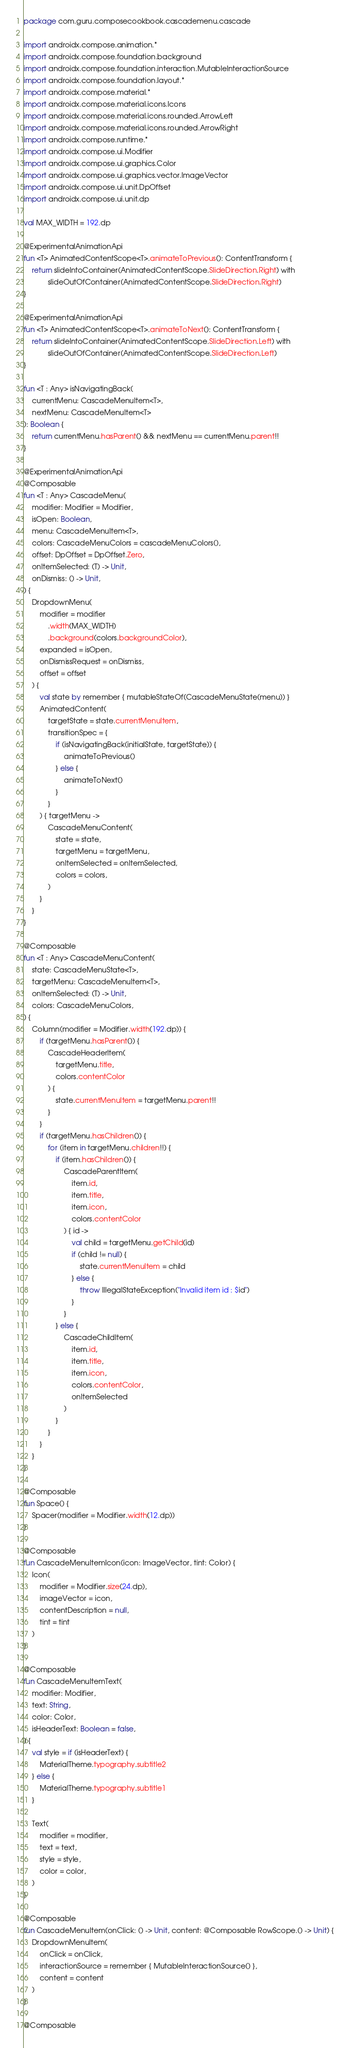<code> <loc_0><loc_0><loc_500><loc_500><_Kotlin_>package com.guru.composecookbook.cascademenu.cascade

import androidx.compose.animation.*
import androidx.compose.foundation.background
import androidx.compose.foundation.interaction.MutableInteractionSource
import androidx.compose.foundation.layout.*
import androidx.compose.material.*
import androidx.compose.material.icons.Icons
import androidx.compose.material.icons.rounded.ArrowLeft
import androidx.compose.material.icons.rounded.ArrowRight
import androidx.compose.runtime.*
import androidx.compose.ui.Modifier
import androidx.compose.ui.graphics.Color
import androidx.compose.ui.graphics.vector.ImageVector
import androidx.compose.ui.unit.DpOffset
import androidx.compose.ui.unit.dp

val MAX_WIDTH = 192.dp

@ExperimentalAnimationApi
fun <T> AnimatedContentScope<T>.animateToPrevious(): ContentTransform {
    return slideIntoContainer(AnimatedContentScope.SlideDirection.Right) with
            slideOutOfContainer(AnimatedContentScope.SlideDirection.Right)
}

@ExperimentalAnimationApi
fun <T> AnimatedContentScope<T>.animateToNext(): ContentTransform {
    return slideIntoContainer(AnimatedContentScope.SlideDirection.Left) with
            slideOutOfContainer(AnimatedContentScope.SlideDirection.Left)
}

fun <T : Any> isNavigatingBack(
    currentMenu: CascadeMenuItem<T>,
    nextMenu: CascadeMenuItem<T>
): Boolean {
    return currentMenu.hasParent() && nextMenu == currentMenu.parent!!
}

@ExperimentalAnimationApi
@Composable
fun <T : Any> CascadeMenu(
    modifier: Modifier = Modifier,
    isOpen: Boolean,
    menu: CascadeMenuItem<T>,
    colors: CascadeMenuColors = cascadeMenuColors(),
    offset: DpOffset = DpOffset.Zero,
    onItemSelected: (T) -> Unit,
    onDismiss: () -> Unit,
) {
    DropdownMenu(
        modifier = modifier
            .width(MAX_WIDTH)
            .background(colors.backgroundColor),
        expanded = isOpen,
        onDismissRequest = onDismiss,
        offset = offset
    ) {
        val state by remember { mutableStateOf(CascadeMenuState(menu)) }
        AnimatedContent(
            targetState = state.currentMenuItem,
            transitionSpec = {
                if (isNavigatingBack(initialState, targetState)) {
                    animateToPrevious()
                } else {
                    animateToNext()
                }
            }
        ) { targetMenu ->
            CascadeMenuContent(
                state = state,
                targetMenu = targetMenu,
                onItemSelected = onItemSelected,
                colors = colors,
            )
        }
    }
}

@Composable
fun <T : Any> CascadeMenuContent(
    state: CascadeMenuState<T>,
    targetMenu: CascadeMenuItem<T>,
    onItemSelected: (T) -> Unit,
    colors: CascadeMenuColors,
) {
    Column(modifier = Modifier.width(192.dp)) {
        if (targetMenu.hasParent()) {
            CascadeHeaderItem(
                targetMenu.title,
                colors.contentColor
            ) {
                state.currentMenuItem = targetMenu.parent!!
            }
        }
        if (targetMenu.hasChildren()) {
            for (item in targetMenu.children!!) {
                if (item.hasChildren()) {
                    CascadeParentItem(
                        item.id,
                        item.title,
                        item.icon,
                        colors.contentColor
                    ) { id ->
                        val child = targetMenu.getChild(id)
                        if (child != null) {
                            state.currentMenuItem = child
                        } else {
                            throw IllegalStateException("Invalid item id : $id")
                        }
                    }
                } else {
                    CascadeChildItem(
                        item.id,
                        item.title,
                        item.icon,
                        colors.contentColor,
                        onItemSelected
                    )
                }
            }
        }
    }
}

@Composable
fun Space() {
    Spacer(modifier = Modifier.width(12.dp))
}

@Composable
fun CascadeMenuItemIcon(icon: ImageVector, tint: Color) {
    Icon(
        modifier = Modifier.size(24.dp),
        imageVector = icon,
        contentDescription = null,
        tint = tint
    )
}

@Composable
fun CascadeMenuItemText(
    modifier: Modifier,
    text: String,
    color: Color,
    isHeaderText: Boolean = false,
) {
    val style = if (isHeaderText) {
        MaterialTheme.typography.subtitle2
    } else {
        MaterialTheme.typography.subtitle1
    }

    Text(
        modifier = modifier,
        text = text,
        style = style,
        color = color,
    )
}

@Composable
fun CascadeMenuItem(onClick: () -> Unit, content: @Composable RowScope.() -> Unit) {
    DropdownMenuItem(
        onClick = onClick,
        interactionSource = remember { MutableInteractionSource() },
        content = content
    )
}

@Composable</code> 